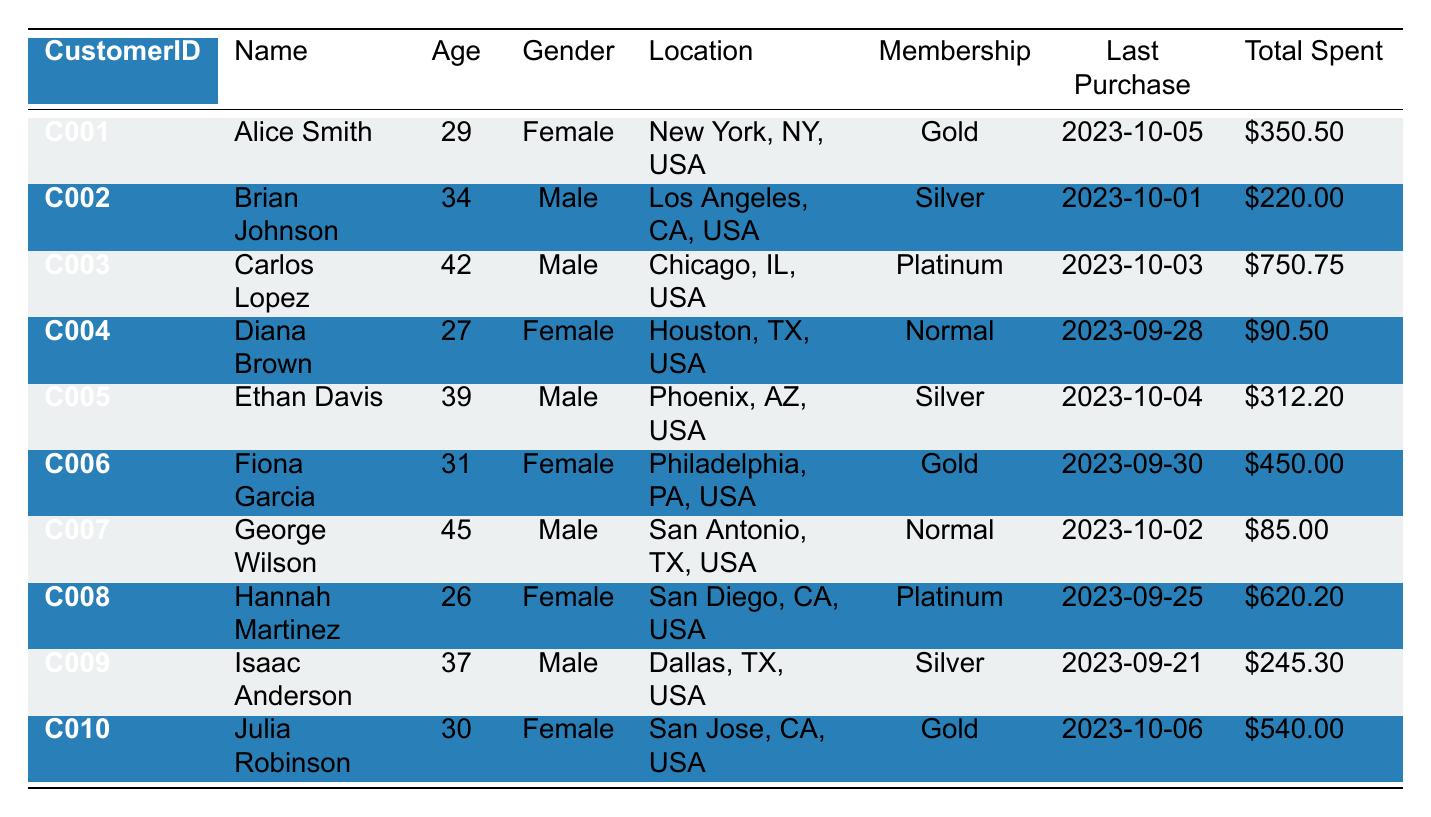What is the total amount spent by Carlos Lopez? Carlos Lopez's Total Spent can be found directly in the table, which states it is 750.75.
Answer: 750.75 How many customers have a Gold membership? The table shows three entries with a MembershipStatus of Gold: Alice Smith, Fiona Garcia, and Julia Robinson. Therefore, there are three customers with a Gold membership.
Answer: 3 What is the average age of all customers? To find the average age, we add the ages of all customers: 29 + 34 + 42 + 27 + 39 + 31 + 45 + 26 + 37 + 30 =  339. There are 10 customers, so the average age is 339 divided by 10, which equals 33.9.
Answer: 33.9 Is George Wilson's Last Purchase Date more recent than Isaac Anderson's? George Wilson's Last Purchase Date is 2023-10-02, while Isaac Anderson's is 2023-09-21. Since 2023-10-02 is later than 2023-09-21, the statement is true.
Answer: Yes What is the total amount spent by customers with a Platinum membership? The customers with a Platinum membership are Carlos Lopez and Hannah Martinez. Their reported Total Spent amounts are 750.75 and 620.20, respectively. Adding these amounts gives 750.75 + 620.20 = 1370.95.
Answer: 1370.95 